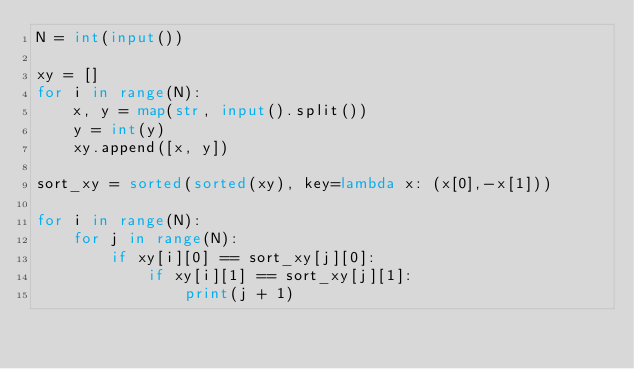Convert code to text. <code><loc_0><loc_0><loc_500><loc_500><_Python_>N = int(input())

xy = []
for i in range(N):
    x, y = map(str, input().split())
    y = int(y)
    xy.append([x, y])

sort_xy = sorted(sorted(xy), key=lambda x: (x[0],-x[1]))

for i in range(N):
    for j in range(N):
        if xy[i][0] == sort_xy[j][0]:
            if xy[i][1] == sort_xy[j][1]:
                print(j + 1)
                </code> 